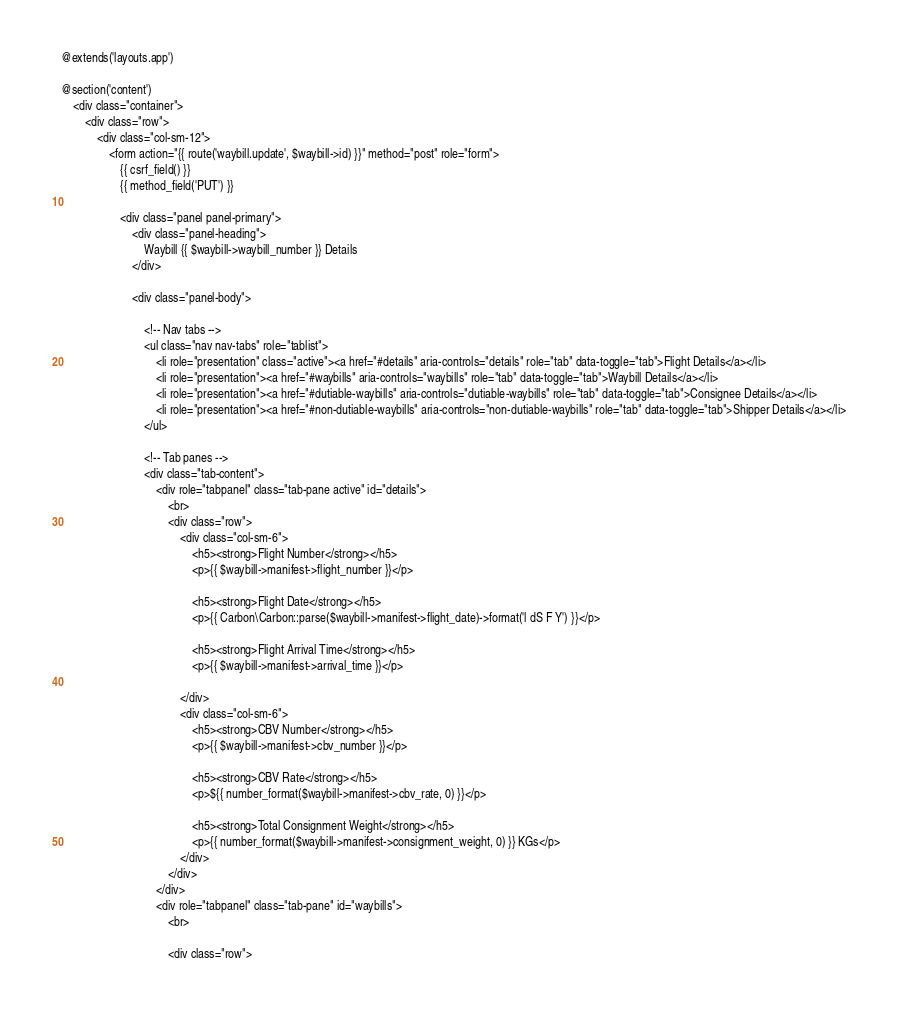<code> <loc_0><loc_0><loc_500><loc_500><_PHP_>@extends('layouts.app')

@section('content')
    <div class="container">
        <div class="row">
            <div class="col-sm-12">
                <form action="{{ route('waybill.update', $waybill->id) }}" method="post" role="form">
                    {{ csrf_field() }}
                    {{ method_field('PUT') }}

                    <div class="panel panel-primary">
                        <div class="panel-heading">
                            Waybill {{ $waybill->waybill_number }} Details
                        </div>

                        <div class="panel-body">

                            <!-- Nav tabs -->
                            <ul class="nav nav-tabs" role="tablist">
                                <li role="presentation" class="active"><a href="#details" aria-controls="details" role="tab" data-toggle="tab">Flight Details</a></li>
                                <li role="presentation"><a href="#waybills" aria-controls="waybills" role="tab" data-toggle="tab">Waybill Details</a></li>
                                <li role="presentation"><a href="#dutiable-waybills" aria-controls="dutiable-waybills" role="tab" data-toggle="tab">Consignee Details</a></li>
                                <li role="presentation"><a href="#non-dutiable-waybills" aria-controls="non-dutiable-waybills" role="tab" data-toggle="tab">Shipper Details</a></li>
                            </ul>

                            <!-- Tab panes -->
                            <div class="tab-content">
                                <div role="tabpanel" class="tab-pane active" id="details">
                                    <br>
                                    <div class="row">
                                        <div class="col-sm-6">
                                            <h5><strong>Flight Number</strong></h5>
                                            <p>{{ $waybill->manifest->flight_number }}</p>

                                            <h5><strong>Flight Date</strong></h5>
                                            <p>{{ Carbon\Carbon::parse($waybill->manifest->flight_date)->format('l dS F Y') }}</p>

                                            <h5><strong>Flight Arrival Time</strong></h5>
                                            <p>{{ $waybill->manifest->arrival_time }}</p>

                                        </div>
                                        <div class="col-sm-6">
                                            <h5><strong>CBV Number</strong></h5>
                                            <p>{{ $waybill->manifest->cbv_number }}</p>

                                            <h5><strong>CBV Rate</strong></h5>
                                            <p>${{ number_format($waybill->manifest->cbv_rate, 0) }}</p>

                                            <h5><strong>Total Consignment Weight</strong></h5>
                                            <p>{{ number_format($waybill->manifest->consignment_weight, 0) }} KGs</p>
                                        </div>
                                    </div>
                                </div>
                                <div role="tabpanel" class="tab-pane" id="waybills">
                                    <br>

                                    <div class="row"></code> 